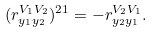Convert formula to latex. <formula><loc_0><loc_0><loc_500><loc_500>( r ^ { V _ { 1 } V _ { 2 } } _ { y _ { 1 } y _ { 2 } } ) ^ { 2 1 } = - r ^ { V _ { 2 } V _ { 1 } } _ { y _ { 2 } y _ { 1 } } .</formula> 